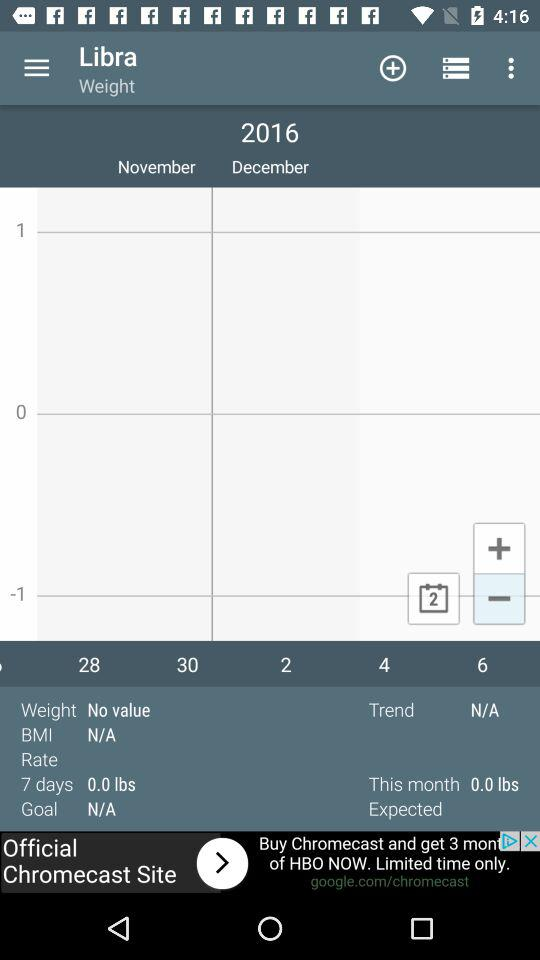What is the BMI? The BMI is N/A. 